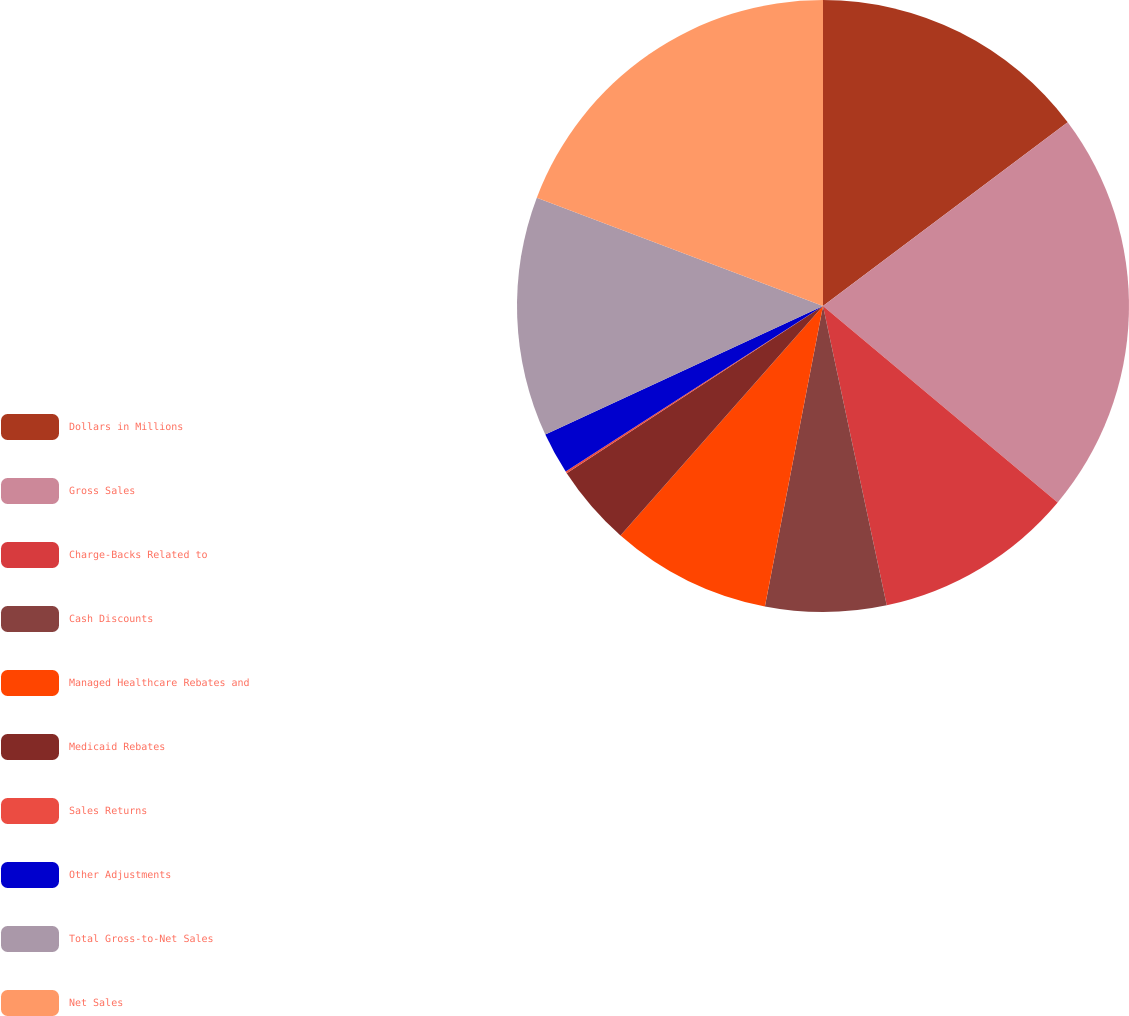Convert chart to OTSL. <chart><loc_0><loc_0><loc_500><loc_500><pie_chart><fcel>Dollars in Millions<fcel>Gross Sales<fcel>Charge-Backs Related to<fcel>Cash Discounts<fcel>Managed Healthcare Rebates and<fcel>Medicaid Rebates<fcel>Sales Returns<fcel>Other Adjustments<fcel>Total Gross-to-Net Sales<fcel>Net Sales<nl><fcel>14.75%<fcel>21.34%<fcel>10.57%<fcel>6.38%<fcel>8.47%<fcel>4.29%<fcel>0.1%<fcel>2.2%<fcel>12.66%<fcel>19.24%<nl></chart> 